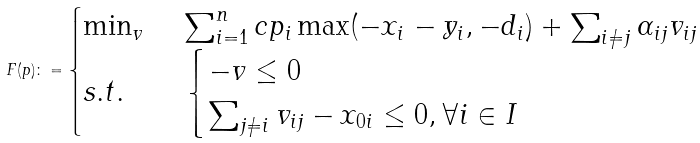<formula> <loc_0><loc_0><loc_500><loc_500>F ( p ) \colon = \begin{cases} \min _ { v } & \sum _ { i = 1 } ^ { n } c p _ { i } \max ( - x _ { i } - y _ { i } , - d _ { i } ) + \sum _ { i \neq j } \alpha _ { i j } v _ { i j } \\ s . t . \quad & \begin{cases} - v \leq 0 \\ \sum _ { j \neq i } v _ { i j } - x _ { 0 i } \leq 0 , \forall i \in I \end{cases} \end{cases}</formula> 